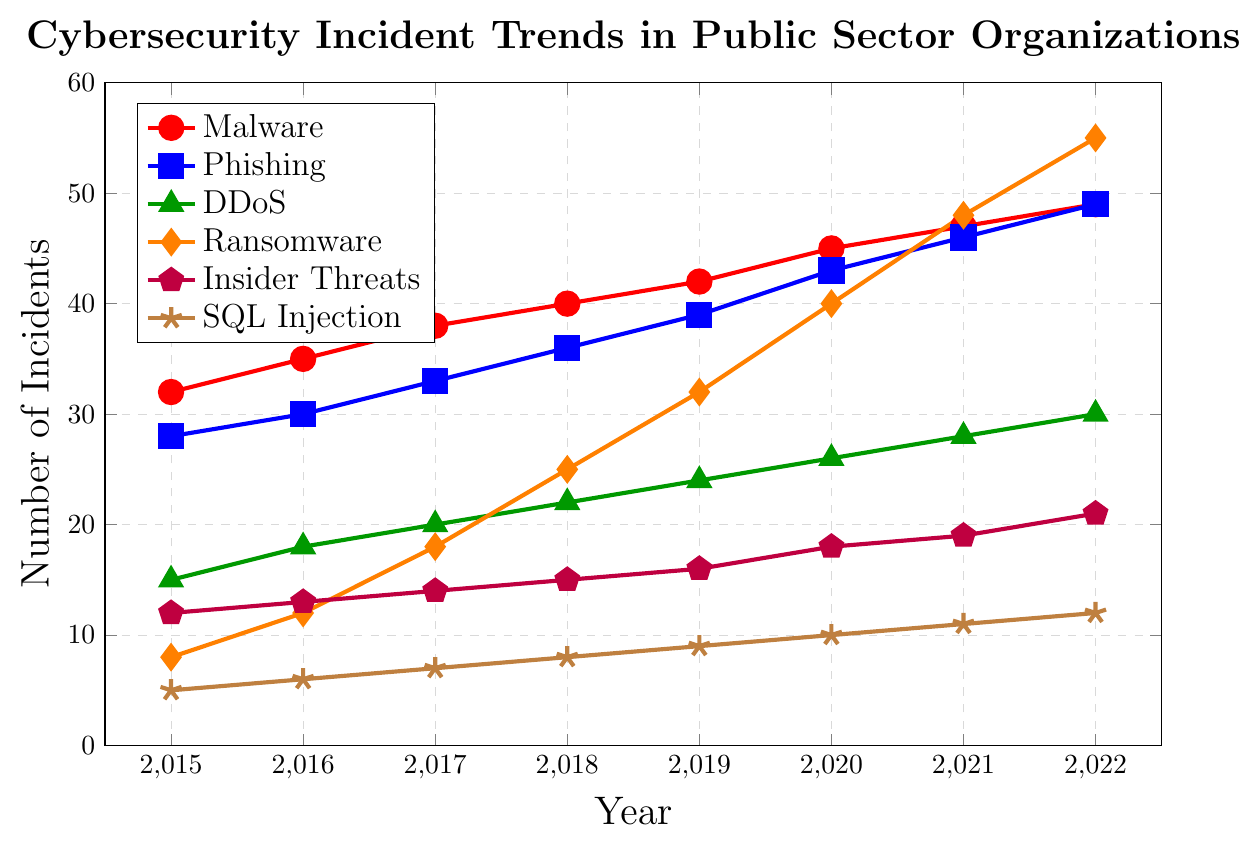Which attack type had the highest number of incidents in 2022? In 2022, the line representing Ransomware is the highest among all other lines on the graph.
Answer: Ransomware What is the difference in the number of Phishing incidents between 2022 and 2015? In 2015, the number of Phishing incidents was 28, and in 2022 it was 49. Subtracting 28 from 49 gives 21.
Answer: 21 Which year did Malware incidents first reach 40 or more? The Malware line first reaches 40 at the point representing the year 2018.
Answer: 2018 How many more DDoS incidents were there in 2019 compared to 2015? In 2015, there were 15 DDoS incidents, and in 2019, there were 24. Subtracting 15 from 24 gives 9.
Answer: 9 What is the average number of incidents for SQL Injection attacks over the 8 years? SQL Injection incidents across the years are: 5, 6, 7, 8, 9, 10, 11, 12. Summing these gives 68, and dividing by the number of years (8) gives 8.5.
Answer: 8.5 Which attack type showed the most consistent increase without any dips from 2015 to 2022? The trends for both Malware and Phishing show a continuous increase without any dips throughout the years.
Answer: Malware or Phishing Compare the number of Insider Threat incidents in 2020 to the number of Ransomware incidents in 2016. Which is higher and by how much? In 2020, there were 18 Insider Threat incidents. In 2016, there were 12 Ransomware incidents. Subtracting 12 from 18 gives 6, thus Insider Threats were higher by 6 incidents.
Answer: Insider Threats by 6 What is the visual difference between the line for DDoS attacks and the line for SQL Injection attacks? The line for DDoS attacks is green and marked with triangles, while the line for SQL Injection attacks is brown and marked with stars.
Answer: DDoS is green with triangles, SQL Injection is brown with stars Which attack type had the smallest increase in the number of incidents from 2015 to 2022? To find the smallest increase, compare the difference between 2022 and 2015 for each attack type. Insider Threats increased from 12 to 21, which is an increase of 9. No other attack type had a smaller increase.
Answer: Insider Threats What is the total number of incidents for Ransomware and Phishing combined in 2021? For 2021, Ransomware incidents are 48 and Phishing incidents are 46. Adding these gives 48 + 46 = 94.
Answer: 94 